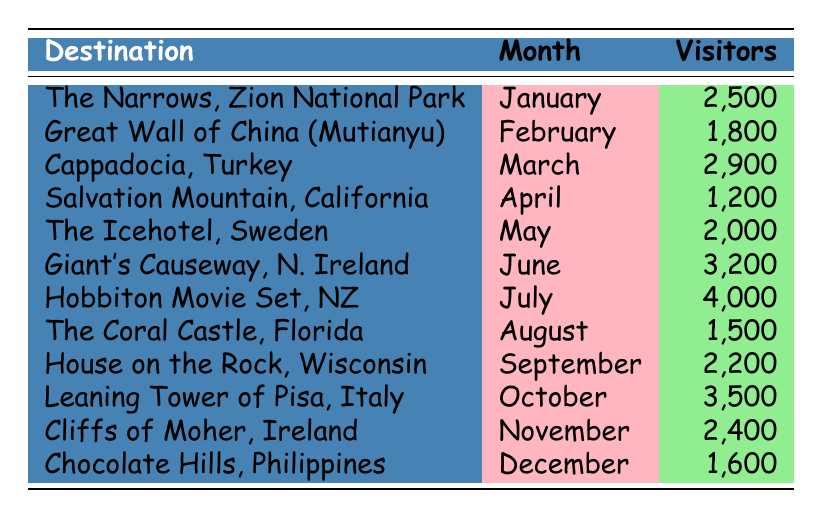What are the visitor numbers for the Giant's Causeway in June? The table lists the Giant's Causeway, Northern Ireland as having 3,200 visitors in June.
Answer: 3,200 What month had the lowest visitor count among these destinations? By comparing all the visitor numbers in the table, I can see that Salvation Mountain, California had the lowest count with 1,200 visitors in April.
Answer: April How many visitors did Hobbiton Movie Set in New Zealand have in July? The table shows that Hobbiton Movie Set in New Zealand had 4,000 visitors in July.
Answer: 4,000 Which destination had more visitors, the Cliffs of Moher or the House on the Rock? Looking at the visitor numbers, the Cliffs of Moher had 2,400 visitors in November, whereas the House on the Rock had 2,200 visitors in September. Thus, Cliffs of Moher had more visitors.
Answer: Cliffs of Moher What is the total number of visitors to all the destinations from January to June? To find the total visitors, I need to sum the visitors from each destination from January to June: 2500 + 1800 + 2900 + 1200 + 2000 + 3200 = 13600.
Answer: 13,600 Did the Great Wall of China receive more visitors than the Coral Castle? The Great Wall of China (Mutianyu Section) had 1,800 visitors, while the Coral Castle had 1,500 visitors. Since 1,800 is greater than 1,500, the answer is yes.
Answer: Yes Which month had the highest visitor count and what was it? By checking through the table, I see that July had the highest visitor count with Hobbiton Movie Set recording 4,000 visitors.
Answer: July, 4,000 Calculate the average number of visitors to the destinations from August to December. I need to add the visitors from those months: 1500 + 2200 + 3500 + 2400 + 1600 = 11800. There are 5 months, so I divide: 11800 / 5 = 2360.
Answer: 2,360 Is it true that there were more visitors in October than in May? In October, the Leaning Tower of Pisa had 3,500 visitors while in May, The Icehotel had 2,000 visitors. Since 3,500 is greater than 2,000, the statement is true.
Answer: Yes 